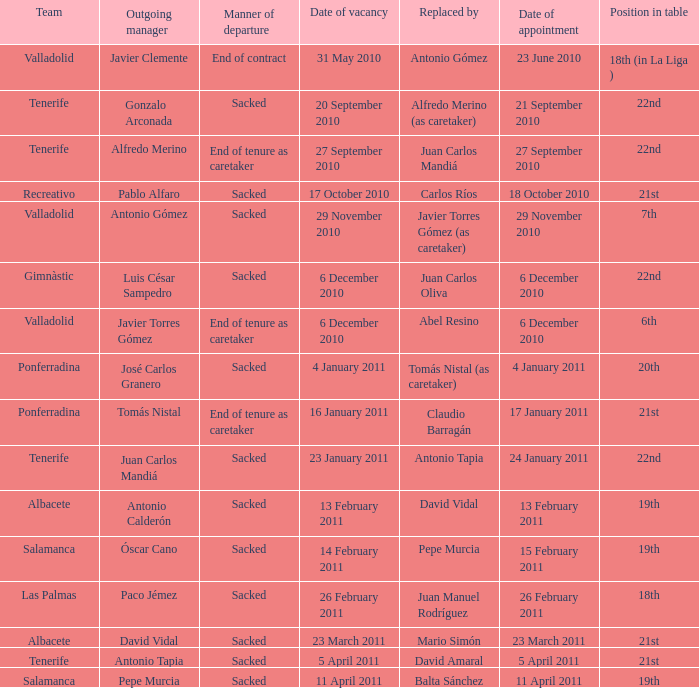How many teams had an appointment date of 11 april 2011 1.0. 